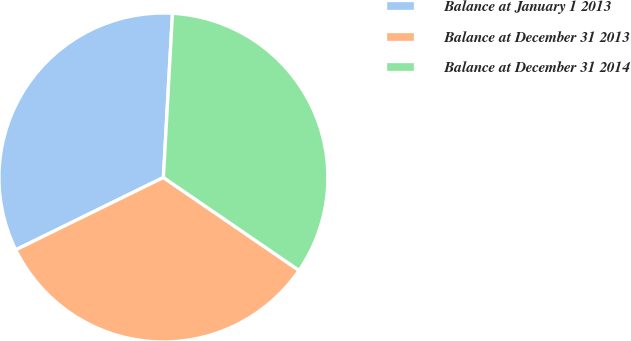Convert chart. <chart><loc_0><loc_0><loc_500><loc_500><pie_chart><fcel>Balance at January 1 2013<fcel>Balance at December 31 2013<fcel>Balance at December 31 2014<nl><fcel>33.13%<fcel>33.19%<fcel>33.68%<nl></chart> 